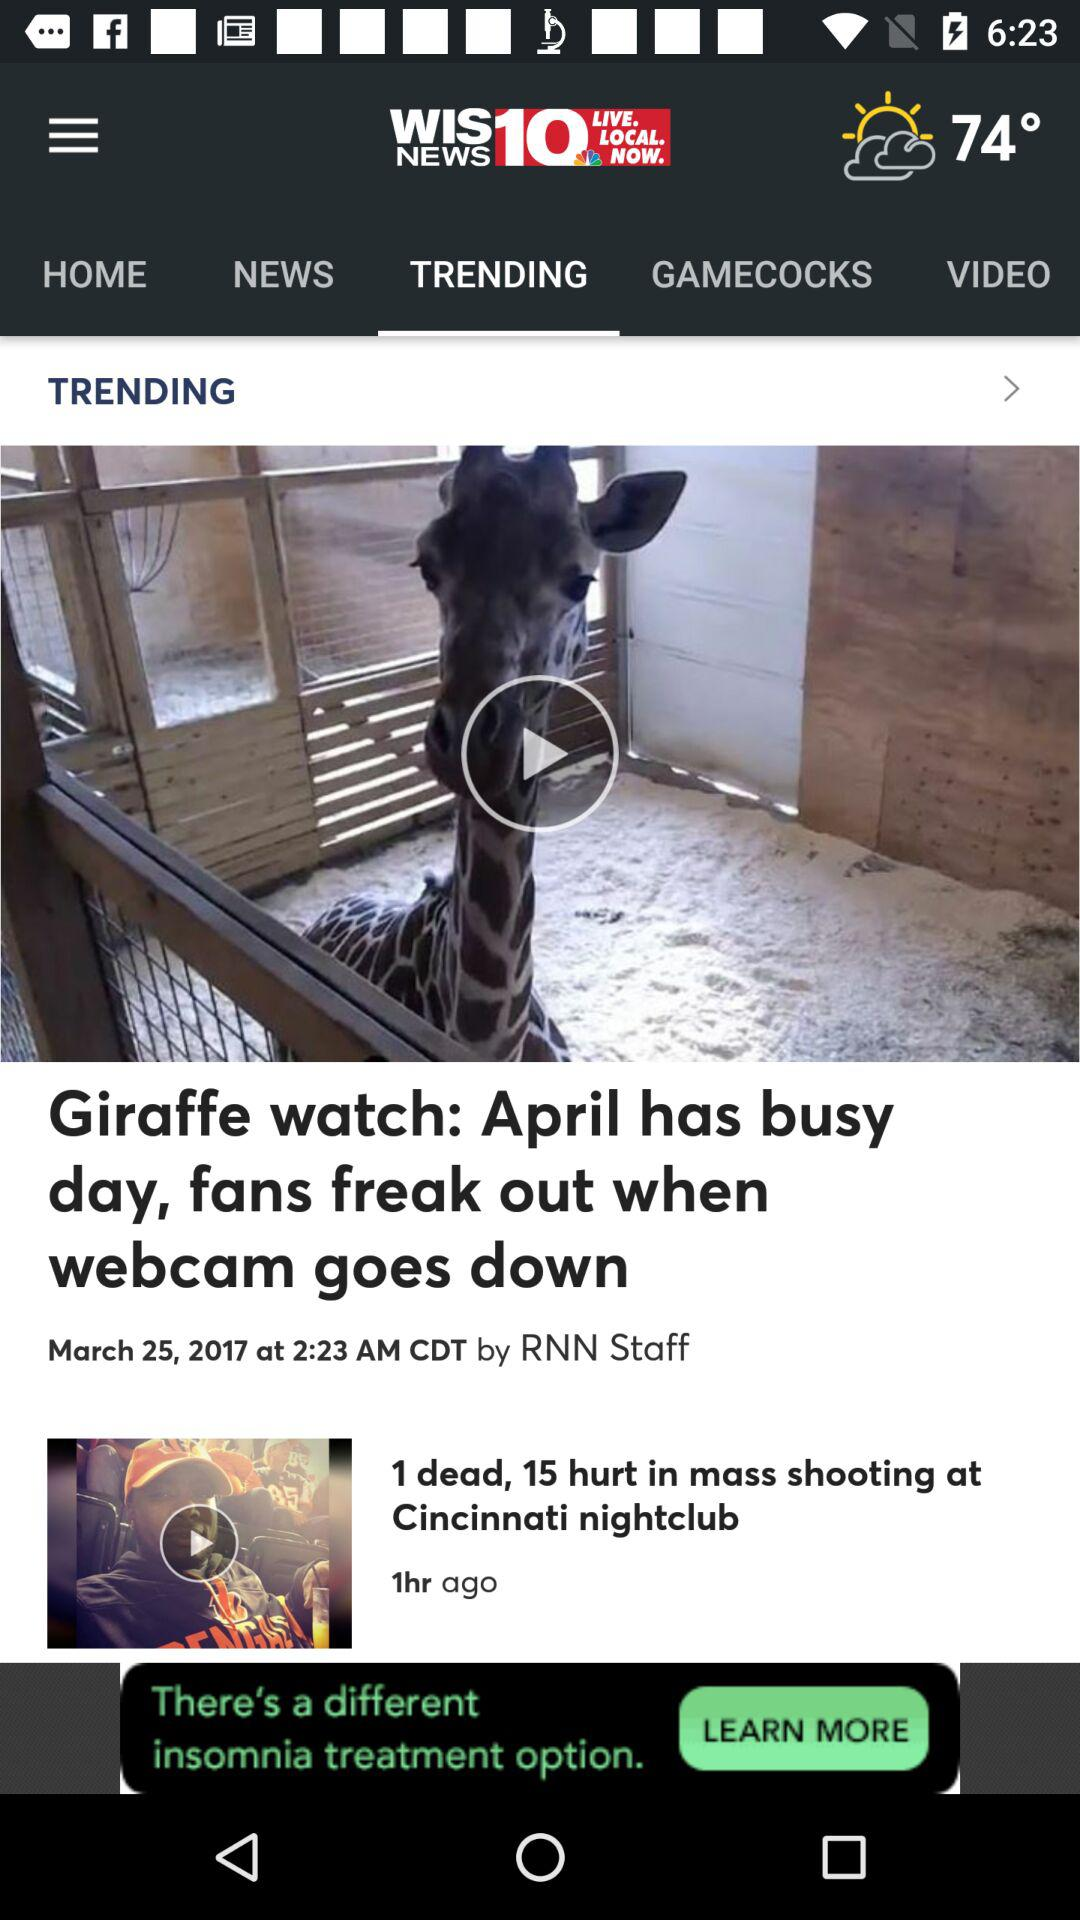Which tab is selected? The selected tab is "TRENDING". 